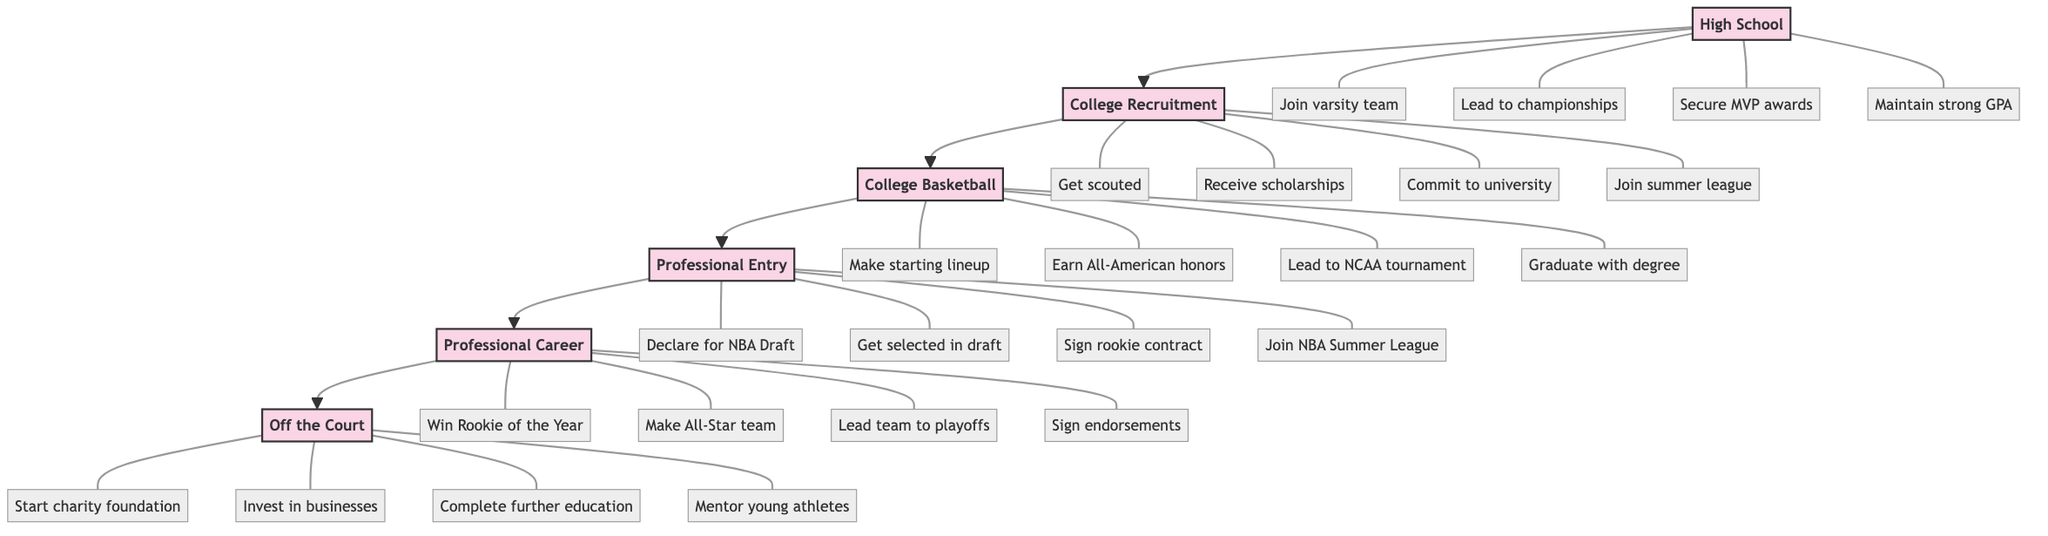What is the first stage in the career progression? The diagram shows a clear sequence starting with "High School," which is the first stage in the career progression.
Answer: High School How many milestones are listed under the College Basketball stage? Under the College Basketball stage, there are four milestones: "Make the starting lineup," "Earn All-American honors," "Lead team to NCAA tournament," and "Graduate with a degree." Therefore, the count of milestones is four.
Answer: 4 What milestone follows “Get scouted” in the College Recruitment stage? The diagram displays a sequence of milestones under the College Recruitment stage. The milestone "Receive scholarship offers" directly follows "Get scouted."
Answer: Receive scholarship offers Which stage includes the milestone “Win Rookie of the Year”? The milestone "Win Rookie of the Year" is listed under the "Professional Career" stage in the diagram.
Answer: Professional Career How many total stages are represented in the career progression diagram? The diagram shows a total of six distinct stages: "High School," "College Recruitment," "College Basketball," "Professional Entry," "Professional Career," and "Off the Court." Therefore, the total count is six.
Answer: 6 In the Professional Entry stage, what is the last milestone? Analyzing the Professional Entry stage, the last milestone listed is "Join NBA Summer League," which is the final milestone in that sequence.
Answer: Join NBA Summer League Which two milestones are connected to the "Off the Court" stage? The two milestones connected to the "Off the Court" stage are "Start a charity foundation" and "Invest in business ventures." These are part of the milestones directly linked after that stage.
Answer: Start a charity foundation, Invest in business ventures What is the relationship between the College Basketball and Professional Entry stages? The relationship between the College Basketball and Professional Entry stages is sequential, meaning that College Basketball leads directly into the Professional Entry stage, indicating progression from one stage to the next in career development.
Answer: Sequential progression Which stage has the milestone "Lead team to playoffs"? The milestone "Lead team to playoffs" is included in the "Professional Career" stage based on the diagram's organization of milestones under each stage.
Answer: Professional Career 